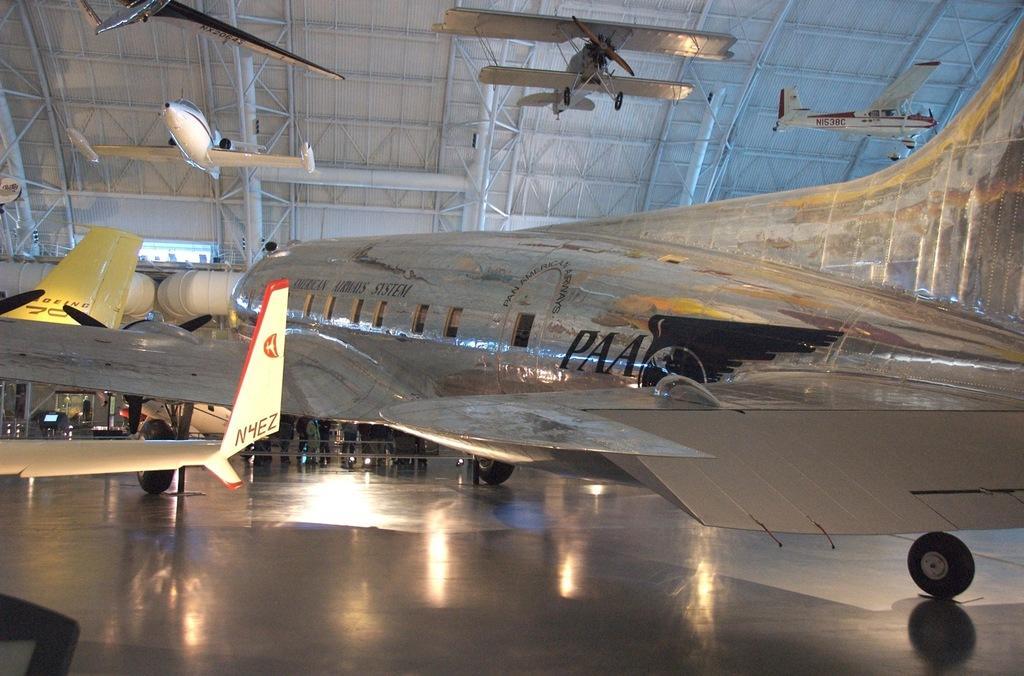Please provide a concise description of this image. In this image we can see there is an airplane on the floor, behind the airplane there are a few people standing. At the top of the image there are few airplanes. 